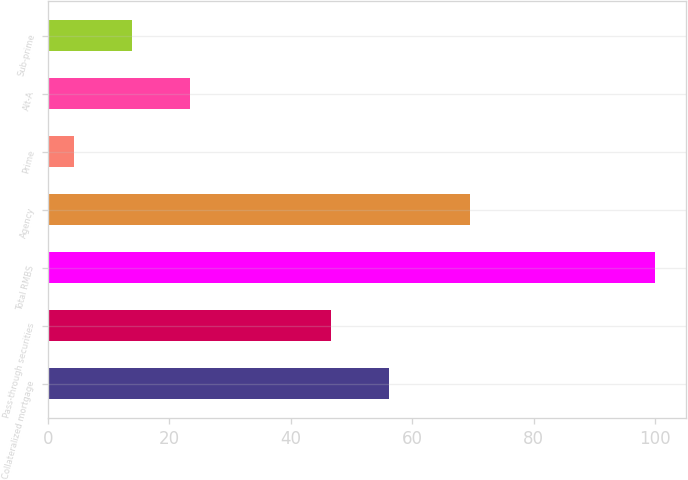<chart> <loc_0><loc_0><loc_500><loc_500><bar_chart><fcel>Collateralized mortgage<fcel>Pass-through securities<fcel>Total RMBS<fcel>Agency<fcel>Prime<fcel>Alt-A<fcel>Sub-prime<nl><fcel>56.18<fcel>46.6<fcel>100<fcel>69.5<fcel>4.2<fcel>23.36<fcel>13.78<nl></chart> 